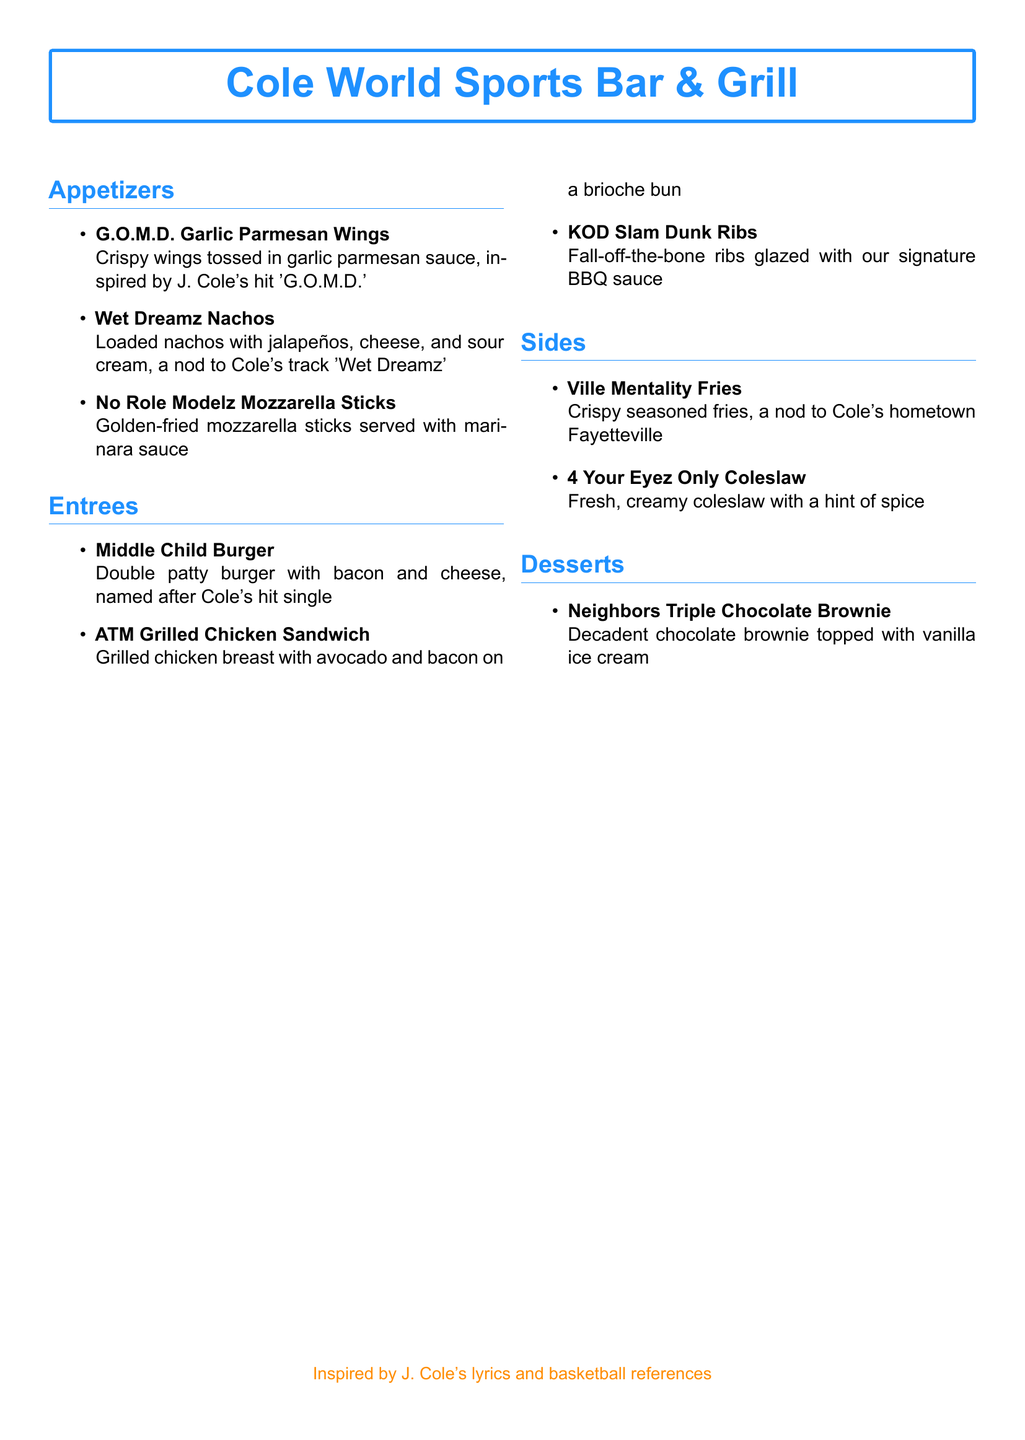What is the name of the sports bar? The title at the top of the document specifies the name of the restaurant menu.
Answer: Cole World Sports Bar & Grill How many appetizers are listed in the menu? The document provides a list of appetizers, counting them gives the total.
Answer: 3 What is the signature dessert? The dessert section highlights a specific item that stands out in its description.
Answer: Neighbors Triple Chocolate Brownie Which appetizer is inspired by 'Wet Dreamz'? The document mentions specific appetizers with references to J. Cole's songs.
Answer: Wet Dreamz Nachos What type of burger is featured in the entree section? The menu lists the entree and describes its characteristics.
Answer: Middle Child Burger Which side is associated with J. Cole's hometown? The side dish section includes a specific reference to Cole's roots.
Answer: Ville Mentality Fries How many entrees are listed on the menu? The number of items listed under the entrees section can be counted.
Answer: 3 What is the main ingredient in the 'ATM Grilled Chicken Sandwich'? The entree description mentions the key components of the dish.
Answer: Grilled chicken breast What type of sauce is used for the KOD Slam Dunk Ribs? The document describes the ribs and mentions the specific condiment used.
Answer: BBQ sauce 